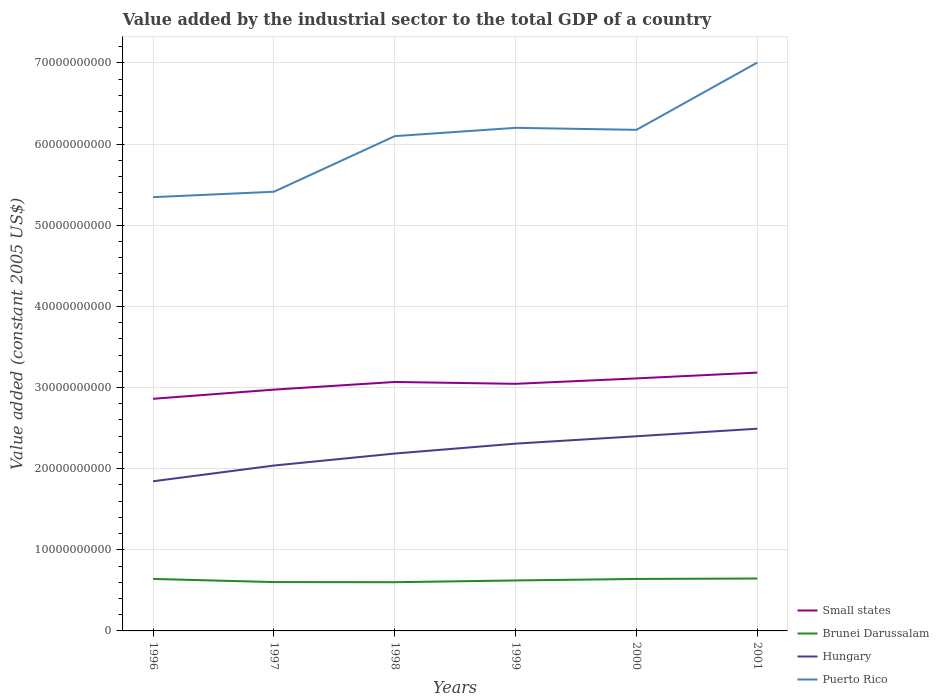Is the number of lines equal to the number of legend labels?
Offer a very short reply. Yes. Across all years, what is the maximum value added by the industrial sector in Small states?
Your answer should be very brief. 2.86e+1. In which year was the value added by the industrial sector in Hungary maximum?
Provide a short and direct response. 1996. What is the total value added by the industrial sector in Small states in the graph?
Offer a very short reply. -2.07e+09. What is the difference between the highest and the second highest value added by the industrial sector in Hungary?
Your answer should be very brief. 6.48e+09. How many lines are there?
Provide a short and direct response. 4. How many years are there in the graph?
Your answer should be very brief. 6. What is the difference between two consecutive major ticks on the Y-axis?
Offer a very short reply. 1.00e+1. Are the values on the major ticks of Y-axis written in scientific E-notation?
Your answer should be very brief. No. Where does the legend appear in the graph?
Provide a short and direct response. Bottom right. How many legend labels are there?
Provide a succinct answer. 4. What is the title of the graph?
Your answer should be very brief. Value added by the industrial sector to the total GDP of a country. What is the label or title of the X-axis?
Offer a terse response. Years. What is the label or title of the Y-axis?
Offer a terse response. Value added (constant 2005 US$). What is the Value added (constant 2005 US$) of Small states in 1996?
Provide a succinct answer. 2.86e+1. What is the Value added (constant 2005 US$) of Brunei Darussalam in 1996?
Offer a very short reply. 6.41e+09. What is the Value added (constant 2005 US$) of Hungary in 1996?
Ensure brevity in your answer.  1.84e+1. What is the Value added (constant 2005 US$) of Puerto Rico in 1996?
Give a very brief answer. 5.35e+1. What is the Value added (constant 2005 US$) in Small states in 1997?
Make the answer very short. 2.97e+1. What is the Value added (constant 2005 US$) in Brunei Darussalam in 1997?
Provide a succinct answer. 6.02e+09. What is the Value added (constant 2005 US$) of Hungary in 1997?
Offer a very short reply. 2.04e+1. What is the Value added (constant 2005 US$) in Puerto Rico in 1997?
Your answer should be compact. 5.41e+1. What is the Value added (constant 2005 US$) of Small states in 1998?
Provide a succinct answer. 3.07e+1. What is the Value added (constant 2005 US$) in Brunei Darussalam in 1998?
Your answer should be compact. 6.00e+09. What is the Value added (constant 2005 US$) in Hungary in 1998?
Give a very brief answer. 2.19e+1. What is the Value added (constant 2005 US$) of Puerto Rico in 1998?
Provide a succinct answer. 6.10e+1. What is the Value added (constant 2005 US$) in Small states in 1999?
Offer a terse response. 3.05e+1. What is the Value added (constant 2005 US$) of Brunei Darussalam in 1999?
Give a very brief answer. 6.22e+09. What is the Value added (constant 2005 US$) of Hungary in 1999?
Give a very brief answer. 2.31e+1. What is the Value added (constant 2005 US$) in Puerto Rico in 1999?
Your answer should be very brief. 6.20e+1. What is the Value added (constant 2005 US$) in Small states in 2000?
Offer a terse response. 3.11e+1. What is the Value added (constant 2005 US$) of Brunei Darussalam in 2000?
Your response must be concise. 6.40e+09. What is the Value added (constant 2005 US$) of Hungary in 2000?
Offer a very short reply. 2.40e+1. What is the Value added (constant 2005 US$) of Puerto Rico in 2000?
Give a very brief answer. 6.18e+1. What is the Value added (constant 2005 US$) in Small states in 2001?
Offer a very short reply. 3.18e+1. What is the Value added (constant 2005 US$) of Brunei Darussalam in 2001?
Ensure brevity in your answer.  6.46e+09. What is the Value added (constant 2005 US$) in Hungary in 2001?
Offer a terse response. 2.49e+1. What is the Value added (constant 2005 US$) in Puerto Rico in 2001?
Ensure brevity in your answer.  7.00e+1. Across all years, what is the maximum Value added (constant 2005 US$) in Small states?
Make the answer very short. 3.18e+1. Across all years, what is the maximum Value added (constant 2005 US$) in Brunei Darussalam?
Give a very brief answer. 6.46e+09. Across all years, what is the maximum Value added (constant 2005 US$) of Hungary?
Give a very brief answer. 2.49e+1. Across all years, what is the maximum Value added (constant 2005 US$) in Puerto Rico?
Offer a terse response. 7.00e+1. Across all years, what is the minimum Value added (constant 2005 US$) in Small states?
Provide a succinct answer. 2.86e+1. Across all years, what is the minimum Value added (constant 2005 US$) of Brunei Darussalam?
Keep it short and to the point. 6.00e+09. Across all years, what is the minimum Value added (constant 2005 US$) in Hungary?
Keep it short and to the point. 1.84e+1. Across all years, what is the minimum Value added (constant 2005 US$) of Puerto Rico?
Offer a terse response. 5.35e+1. What is the total Value added (constant 2005 US$) of Small states in the graph?
Make the answer very short. 1.82e+11. What is the total Value added (constant 2005 US$) in Brunei Darussalam in the graph?
Offer a terse response. 3.75e+1. What is the total Value added (constant 2005 US$) in Hungary in the graph?
Your answer should be compact. 1.33e+11. What is the total Value added (constant 2005 US$) of Puerto Rico in the graph?
Ensure brevity in your answer.  3.62e+11. What is the difference between the Value added (constant 2005 US$) of Small states in 1996 and that in 1997?
Offer a terse response. -1.13e+09. What is the difference between the Value added (constant 2005 US$) in Brunei Darussalam in 1996 and that in 1997?
Give a very brief answer. 3.89e+08. What is the difference between the Value added (constant 2005 US$) in Hungary in 1996 and that in 1997?
Provide a short and direct response. -1.94e+09. What is the difference between the Value added (constant 2005 US$) of Puerto Rico in 1996 and that in 1997?
Ensure brevity in your answer.  -6.69e+08. What is the difference between the Value added (constant 2005 US$) in Small states in 1996 and that in 1998?
Your answer should be compact. -2.07e+09. What is the difference between the Value added (constant 2005 US$) of Brunei Darussalam in 1996 and that in 1998?
Provide a short and direct response. 4.05e+08. What is the difference between the Value added (constant 2005 US$) of Hungary in 1996 and that in 1998?
Offer a very short reply. -3.42e+09. What is the difference between the Value added (constant 2005 US$) in Puerto Rico in 1996 and that in 1998?
Your answer should be compact. -7.52e+09. What is the difference between the Value added (constant 2005 US$) of Small states in 1996 and that in 1999?
Provide a short and direct response. -1.85e+09. What is the difference between the Value added (constant 2005 US$) of Brunei Darussalam in 1996 and that in 1999?
Provide a short and direct response. 1.89e+08. What is the difference between the Value added (constant 2005 US$) of Hungary in 1996 and that in 1999?
Keep it short and to the point. -4.64e+09. What is the difference between the Value added (constant 2005 US$) of Puerto Rico in 1996 and that in 1999?
Your answer should be very brief. -8.54e+09. What is the difference between the Value added (constant 2005 US$) in Small states in 1996 and that in 2000?
Your answer should be very brief. -2.51e+09. What is the difference between the Value added (constant 2005 US$) in Brunei Darussalam in 1996 and that in 2000?
Offer a terse response. 3.78e+06. What is the difference between the Value added (constant 2005 US$) in Hungary in 1996 and that in 2000?
Your answer should be compact. -5.55e+09. What is the difference between the Value added (constant 2005 US$) in Puerto Rico in 1996 and that in 2000?
Offer a terse response. -8.30e+09. What is the difference between the Value added (constant 2005 US$) of Small states in 1996 and that in 2001?
Offer a terse response. -3.23e+09. What is the difference between the Value added (constant 2005 US$) in Brunei Darussalam in 1996 and that in 2001?
Your response must be concise. -4.95e+07. What is the difference between the Value added (constant 2005 US$) in Hungary in 1996 and that in 2001?
Your answer should be very brief. -6.48e+09. What is the difference between the Value added (constant 2005 US$) in Puerto Rico in 1996 and that in 2001?
Make the answer very short. -1.66e+1. What is the difference between the Value added (constant 2005 US$) of Small states in 1997 and that in 1998?
Offer a terse response. -9.44e+08. What is the difference between the Value added (constant 2005 US$) of Brunei Darussalam in 1997 and that in 1998?
Provide a succinct answer. 1.59e+07. What is the difference between the Value added (constant 2005 US$) in Hungary in 1997 and that in 1998?
Your answer should be very brief. -1.48e+09. What is the difference between the Value added (constant 2005 US$) of Puerto Rico in 1997 and that in 1998?
Provide a short and direct response. -6.85e+09. What is the difference between the Value added (constant 2005 US$) in Small states in 1997 and that in 1999?
Your answer should be very brief. -7.16e+08. What is the difference between the Value added (constant 2005 US$) of Brunei Darussalam in 1997 and that in 1999?
Provide a short and direct response. -2.00e+08. What is the difference between the Value added (constant 2005 US$) in Hungary in 1997 and that in 1999?
Give a very brief answer. -2.70e+09. What is the difference between the Value added (constant 2005 US$) of Puerto Rico in 1997 and that in 1999?
Ensure brevity in your answer.  -7.87e+09. What is the difference between the Value added (constant 2005 US$) of Small states in 1997 and that in 2000?
Your response must be concise. -1.38e+09. What is the difference between the Value added (constant 2005 US$) in Brunei Darussalam in 1997 and that in 2000?
Your answer should be compact. -3.85e+08. What is the difference between the Value added (constant 2005 US$) in Hungary in 1997 and that in 2000?
Provide a succinct answer. -3.61e+09. What is the difference between the Value added (constant 2005 US$) in Puerto Rico in 1997 and that in 2000?
Provide a succinct answer. -7.63e+09. What is the difference between the Value added (constant 2005 US$) in Small states in 1997 and that in 2001?
Provide a succinct answer. -2.10e+09. What is the difference between the Value added (constant 2005 US$) of Brunei Darussalam in 1997 and that in 2001?
Make the answer very short. -4.39e+08. What is the difference between the Value added (constant 2005 US$) in Hungary in 1997 and that in 2001?
Your response must be concise. -4.54e+09. What is the difference between the Value added (constant 2005 US$) in Puerto Rico in 1997 and that in 2001?
Offer a very short reply. -1.59e+1. What is the difference between the Value added (constant 2005 US$) in Small states in 1998 and that in 1999?
Give a very brief answer. 2.28e+08. What is the difference between the Value added (constant 2005 US$) of Brunei Darussalam in 1998 and that in 1999?
Offer a very short reply. -2.16e+08. What is the difference between the Value added (constant 2005 US$) of Hungary in 1998 and that in 1999?
Keep it short and to the point. -1.22e+09. What is the difference between the Value added (constant 2005 US$) of Puerto Rico in 1998 and that in 1999?
Offer a terse response. -1.02e+09. What is the difference between the Value added (constant 2005 US$) in Small states in 1998 and that in 2000?
Provide a succinct answer. -4.40e+08. What is the difference between the Value added (constant 2005 US$) of Brunei Darussalam in 1998 and that in 2000?
Your answer should be very brief. -4.01e+08. What is the difference between the Value added (constant 2005 US$) in Hungary in 1998 and that in 2000?
Provide a succinct answer. -2.13e+09. What is the difference between the Value added (constant 2005 US$) of Puerto Rico in 1998 and that in 2000?
Your answer should be very brief. -7.76e+08. What is the difference between the Value added (constant 2005 US$) in Small states in 1998 and that in 2001?
Your answer should be compact. -1.16e+09. What is the difference between the Value added (constant 2005 US$) in Brunei Darussalam in 1998 and that in 2001?
Your answer should be very brief. -4.55e+08. What is the difference between the Value added (constant 2005 US$) of Hungary in 1998 and that in 2001?
Your answer should be compact. -3.06e+09. What is the difference between the Value added (constant 2005 US$) of Puerto Rico in 1998 and that in 2001?
Keep it short and to the point. -9.07e+09. What is the difference between the Value added (constant 2005 US$) of Small states in 1999 and that in 2000?
Your answer should be very brief. -6.68e+08. What is the difference between the Value added (constant 2005 US$) in Brunei Darussalam in 1999 and that in 2000?
Give a very brief answer. -1.85e+08. What is the difference between the Value added (constant 2005 US$) of Hungary in 1999 and that in 2000?
Provide a short and direct response. -9.09e+08. What is the difference between the Value added (constant 2005 US$) of Puerto Rico in 1999 and that in 2000?
Ensure brevity in your answer.  2.48e+08. What is the difference between the Value added (constant 2005 US$) of Small states in 1999 and that in 2001?
Keep it short and to the point. -1.38e+09. What is the difference between the Value added (constant 2005 US$) of Brunei Darussalam in 1999 and that in 2001?
Your answer should be very brief. -2.39e+08. What is the difference between the Value added (constant 2005 US$) of Hungary in 1999 and that in 2001?
Give a very brief answer. -1.84e+09. What is the difference between the Value added (constant 2005 US$) of Puerto Rico in 1999 and that in 2001?
Your response must be concise. -8.04e+09. What is the difference between the Value added (constant 2005 US$) in Small states in 2000 and that in 2001?
Make the answer very short. -7.15e+08. What is the difference between the Value added (constant 2005 US$) of Brunei Darussalam in 2000 and that in 2001?
Your answer should be compact. -5.32e+07. What is the difference between the Value added (constant 2005 US$) in Hungary in 2000 and that in 2001?
Offer a terse response. -9.31e+08. What is the difference between the Value added (constant 2005 US$) of Puerto Rico in 2000 and that in 2001?
Your answer should be very brief. -8.29e+09. What is the difference between the Value added (constant 2005 US$) of Small states in 1996 and the Value added (constant 2005 US$) of Brunei Darussalam in 1997?
Make the answer very short. 2.26e+1. What is the difference between the Value added (constant 2005 US$) of Small states in 1996 and the Value added (constant 2005 US$) of Hungary in 1997?
Offer a terse response. 8.23e+09. What is the difference between the Value added (constant 2005 US$) in Small states in 1996 and the Value added (constant 2005 US$) in Puerto Rico in 1997?
Offer a very short reply. -2.55e+1. What is the difference between the Value added (constant 2005 US$) of Brunei Darussalam in 1996 and the Value added (constant 2005 US$) of Hungary in 1997?
Make the answer very short. -1.40e+1. What is the difference between the Value added (constant 2005 US$) of Brunei Darussalam in 1996 and the Value added (constant 2005 US$) of Puerto Rico in 1997?
Offer a terse response. -4.77e+1. What is the difference between the Value added (constant 2005 US$) of Hungary in 1996 and the Value added (constant 2005 US$) of Puerto Rico in 1997?
Your answer should be compact. -3.57e+1. What is the difference between the Value added (constant 2005 US$) of Small states in 1996 and the Value added (constant 2005 US$) of Brunei Darussalam in 1998?
Your response must be concise. 2.26e+1. What is the difference between the Value added (constant 2005 US$) of Small states in 1996 and the Value added (constant 2005 US$) of Hungary in 1998?
Offer a very short reply. 6.75e+09. What is the difference between the Value added (constant 2005 US$) of Small states in 1996 and the Value added (constant 2005 US$) of Puerto Rico in 1998?
Give a very brief answer. -3.24e+1. What is the difference between the Value added (constant 2005 US$) in Brunei Darussalam in 1996 and the Value added (constant 2005 US$) in Hungary in 1998?
Offer a very short reply. -1.55e+1. What is the difference between the Value added (constant 2005 US$) in Brunei Darussalam in 1996 and the Value added (constant 2005 US$) in Puerto Rico in 1998?
Offer a terse response. -5.46e+1. What is the difference between the Value added (constant 2005 US$) in Hungary in 1996 and the Value added (constant 2005 US$) in Puerto Rico in 1998?
Make the answer very short. -4.25e+1. What is the difference between the Value added (constant 2005 US$) in Small states in 1996 and the Value added (constant 2005 US$) in Brunei Darussalam in 1999?
Offer a terse response. 2.24e+1. What is the difference between the Value added (constant 2005 US$) of Small states in 1996 and the Value added (constant 2005 US$) of Hungary in 1999?
Give a very brief answer. 5.53e+09. What is the difference between the Value added (constant 2005 US$) in Small states in 1996 and the Value added (constant 2005 US$) in Puerto Rico in 1999?
Your answer should be compact. -3.34e+1. What is the difference between the Value added (constant 2005 US$) in Brunei Darussalam in 1996 and the Value added (constant 2005 US$) in Hungary in 1999?
Your response must be concise. -1.67e+1. What is the difference between the Value added (constant 2005 US$) in Brunei Darussalam in 1996 and the Value added (constant 2005 US$) in Puerto Rico in 1999?
Offer a terse response. -5.56e+1. What is the difference between the Value added (constant 2005 US$) in Hungary in 1996 and the Value added (constant 2005 US$) in Puerto Rico in 1999?
Offer a terse response. -4.36e+1. What is the difference between the Value added (constant 2005 US$) of Small states in 1996 and the Value added (constant 2005 US$) of Brunei Darussalam in 2000?
Offer a very short reply. 2.22e+1. What is the difference between the Value added (constant 2005 US$) in Small states in 1996 and the Value added (constant 2005 US$) in Hungary in 2000?
Keep it short and to the point. 4.62e+09. What is the difference between the Value added (constant 2005 US$) in Small states in 1996 and the Value added (constant 2005 US$) in Puerto Rico in 2000?
Your response must be concise. -3.31e+1. What is the difference between the Value added (constant 2005 US$) of Brunei Darussalam in 1996 and the Value added (constant 2005 US$) of Hungary in 2000?
Offer a very short reply. -1.76e+1. What is the difference between the Value added (constant 2005 US$) of Brunei Darussalam in 1996 and the Value added (constant 2005 US$) of Puerto Rico in 2000?
Offer a very short reply. -5.53e+1. What is the difference between the Value added (constant 2005 US$) of Hungary in 1996 and the Value added (constant 2005 US$) of Puerto Rico in 2000?
Give a very brief answer. -4.33e+1. What is the difference between the Value added (constant 2005 US$) of Small states in 1996 and the Value added (constant 2005 US$) of Brunei Darussalam in 2001?
Provide a short and direct response. 2.21e+1. What is the difference between the Value added (constant 2005 US$) in Small states in 1996 and the Value added (constant 2005 US$) in Hungary in 2001?
Provide a short and direct response. 3.69e+09. What is the difference between the Value added (constant 2005 US$) of Small states in 1996 and the Value added (constant 2005 US$) of Puerto Rico in 2001?
Ensure brevity in your answer.  -4.14e+1. What is the difference between the Value added (constant 2005 US$) of Brunei Darussalam in 1996 and the Value added (constant 2005 US$) of Hungary in 2001?
Provide a succinct answer. -1.85e+1. What is the difference between the Value added (constant 2005 US$) in Brunei Darussalam in 1996 and the Value added (constant 2005 US$) in Puerto Rico in 2001?
Your answer should be very brief. -6.36e+1. What is the difference between the Value added (constant 2005 US$) of Hungary in 1996 and the Value added (constant 2005 US$) of Puerto Rico in 2001?
Your answer should be very brief. -5.16e+1. What is the difference between the Value added (constant 2005 US$) in Small states in 1997 and the Value added (constant 2005 US$) in Brunei Darussalam in 1998?
Make the answer very short. 2.37e+1. What is the difference between the Value added (constant 2005 US$) of Small states in 1997 and the Value added (constant 2005 US$) of Hungary in 1998?
Your answer should be compact. 7.88e+09. What is the difference between the Value added (constant 2005 US$) in Small states in 1997 and the Value added (constant 2005 US$) in Puerto Rico in 1998?
Your answer should be very brief. -3.12e+1. What is the difference between the Value added (constant 2005 US$) in Brunei Darussalam in 1997 and the Value added (constant 2005 US$) in Hungary in 1998?
Your answer should be compact. -1.58e+1. What is the difference between the Value added (constant 2005 US$) in Brunei Darussalam in 1997 and the Value added (constant 2005 US$) in Puerto Rico in 1998?
Provide a short and direct response. -5.50e+1. What is the difference between the Value added (constant 2005 US$) of Hungary in 1997 and the Value added (constant 2005 US$) of Puerto Rico in 1998?
Provide a short and direct response. -4.06e+1. What is the difference between the Value added (constant 2005 US$) of Small states in 1997 and the Value added (constant 2005 US$) of Brunei Darussalam in 1999?
Your response must be concise. 2.35e+1. What is the difference between the Value added (constant 2005 US$) in Small states in 1997 and the Value added (constant 2005 US$) in Hungary in 1999?
Provide a short and direct response. 6.66e+09. What is the difference between the Value added (constant 2005 US$) in Small states in 1997 and the Value added (constant 2005 US$) in Puerto Rico in 1999?
Provide a succinct answer. -3.23e+1. What is the difference between the Value added (constant 2005 US$) of Brunei Darussalam in 1997 and the Value added (constant 2005 US$) of Hungary in 1999?
Your answer should be compact. -1.71e+1. What is the difference between the Value added (constant 2005 US$) in Brunei Darussalam in 1997 and the Value added (constant 2005 US$) in Puerto Rico in 1999?
Make the answer very short. -5.60e+1. What is the difference between the Value added (constant 2005 US$) in Hungary in 1997 and the Value added (constant 2005 US$) in Puerto Rico in 1999?
Provide a short and direct response. -4.16e+1. What is the difference between the Value added (constant 2005 US$) of Small states in 1997 and the Value added (constant 2005 US$) of Brunei Darussalam in 2000?
Give a very brief answer. 2.33e+1. What is the difference between the Value added (constant 2005 US$) of Small states in 1997 and the Value added (constant 2005 US$) of Hungary in 2000?
Your answer should be compact. 5.75e+09. What is the difference between the Value added (constant 2005 US$) in Small states in 1997 and the Value added (constant 2005 US$) in Puerto Rico in 2000?
Your response must be concise. -3.20e+1. What is the difference between the Value added (constant 2005 US$) in Brunei Darussalam in 1997 and the Value added (constant 2005 US$) in Hungary in 2000?
Your answer should be very brief. -1.80e+1. What is the difference between the Value added (constant 2005 US$) of Brunei Darussalam in 1997 and the Value added (constant 2005 US$) of Puerto Rico in 2000?
Provide a succinct answer. -5.57e+1. What is the difference between the Value added (constant 2005 US$) in Hungary in 1997 and the Value added (constant 2005 US$) in Puerto Rico in 2000?
Make the answer very short. -4.14e+1. What is the difference between the Value added (constant 2005 US$) of Small states in 1997 and the Value added (constant 2005 US$) of Brunei Darussalam in 2001?
Make the answer very short. 2.33e+1. What is the difference between the Value added (constant 2005 US$) in Small states in 1997 and the Value added (constant 2005 US$) in Hungary in 2001?
Your response must be concise. 4.82e+09. What is the difference between the Value added (constant 2005 US$) in Small states in 1997 and the Value added (constant 2005 US$) in Puerto Rico in 2001?
Offer a terse response. -4.03e+1. What is the difference between the Value added (constant 2005 US$) of Brunei Darussalam in 1997 and the Value added (constant 2005 US$) of Hungary in 2001?
Give a very brief answer. -1.89e+1. What is the difference between the Value added (constant 2005 US$) of Brunei Darussalam in 1997 and the Value added (constant 2005 US$) of Puerto Rico in 2001?
Keep it short and to the point. -6.40e+1. What is the difference between the Value added (constant 2005 US$) of Hungary in 1997 and the Value added (constant 2005 US$) of Puerto Rico in 2001?
Your answer should be compact. -4.97e+1. What is the difference between the Value added (constant 2005 US$) of Small states in 1998 and the Value added (constant 2005 US$) of Brunei Darussalam in 1999?
Offer a terse response. 2.45e+1. What is the difference between the Value added (constant 2005 US$) of Small states in 1998 and the Value added (constant 2005 US$) of Hungary in 1999?
Offer a very short reply. 7.60e+09. What is the difference between the Value added (constant 2005 US$) in Small states in 1998 and the Value added (constant 2005 US$) in Puerto Rico in 1999?
Keep it short and to the point. -3.13e+1. What is the difference between the Value added (constant 2005 US$) of Brunei Darussalam in 1998 and the Value added (constant 2005 US$) of Hungary in 1999?
Make the answer very short. -1.71e+1. What is the difference between the Value added (constant 2005 US$) of Brunei Darussalam in 1998 and the Value added (constant 2005 US$) of Puerto Rico in 1999?
Provide a short and direct response. -5.60e+1. What is the difference between the Value added (constant 2005 US$) of Hungary in 1998 and the Value added (constant 2005 US$) of Puerto Rico in 1999?
Offer a very short reply. -4.01e+1. What is the difference between the Value added (constant 2005 US$) in Small states in 1998 and the Value added (constant 2005 US$) in Brunei Darussalam in 2000?
Offer a very short reply. 2.43e+1. What is the difference between the Value added (constant 2005 US$) in Small states in 1998 and the Value added (constant 2005 US$) in Hungary in 2000?
Offer a terse response. 6.69e+09. What is the difference between the Value added (constant 2005 US$) in Small states in 1998 and the Value added (constant 2005 US$) in Puerto Rico in 2000?
Give a very brief answer. -3.11e+1. What is the difference between the Value added (constant 2005 US$) in Brunei Darussalam in 1998 and the Value added (constant 2005 US$) in Hungary in 2000?
Your answer should be compact. -1.80e+1. What is the difference between the Value added (constant 2005 US$) of Brunei Darussalam in 1998 and the Value added (constant 2005 US$) of Puerto Rico in 2000?
Give a very brief answer. -5.57e+1. What is the difference between the Value added (constant 2005 US$) in Hungary in 1998 and the Value added (constant 2005 US$) in Puerto Rico in 2000?
Offer a terse response. -3.99e+1. What is the difference between the Value added (constant 2005 US$) in Small states in 1998 and the Value added (constant 2005 US$) in Brunei Darussalam in 2001?
Offer a very short reply. 2.42e+1. What is the difference between the Value added (constant 2005 US$) of Small states in 1998 and the Value added (constant 2005 US$) of Hungary in 2001?
Give a very brief answer. 5.76e+09. What is the difference between the Value added (constant 2005 US$) of Small states in 1998 and the Value added (constant 2005 US$) of Puerto Rico in 2001?
Provide a succinct answer. -3.94e+1. What is the difference between the Value added (constant 2005 US$) in Brunei Darussalam in 1998 and the Value added (constant 2005 US$) in Hungary in 2001?
Provide a succinct answer. -1.89e+1. What is the difference between the Value added (constant 2005 US$) of Brunei Darussalam in 1998 and the Value added (constant 2005 US$) of Puerto Rico in 2001?
Offer a terse response. -6.40e+1. What is the difference between the Value added (constant 2005 US$) in Hungary in 1998 and the Value added (constant 2005 US$) in Puerto Rico in 2001?
Your response must be concise. -4.82e+1. What is the difference between the Value added (constant 2005 US$) in Small states in 1999 and the Value added (constant 2005 US$) in Brunei Darussalam in 2000?
Your answer should be compact. 2.40e+1. What is the difference between the Value added (constant 2005 US$) in Small states in 1999 and the Value added (constant 2005 US$) in Hungary in 2000?
Provide a succinct answer. 6.46e+09. What is the difference between the Value added (constant 2005 US$) in Small states in 1999 and the Value added (constant 2005 US$) in Puerto Rico in 2000?
Your response must be concise. -3.13e+1. What is the difference between the Value added (constant 2005 US$) of Brunei Darussalam in 1999 and the Value added (constant 2005 US$) of Hungary in 2000?
Ensure brevity in your answer.  -1.78e+1. What is the difference between the Value added (constant 2005 US$) of Brunei Darussalam in 1999 and the Value added (constant 2005 US$) of Puerto Rico in 2000?
Offer a terse response. -5.55e+1. What is the difference between the Value added (constant 2005 US$) of Hungary in 1999 and the Value added (constant 2005 US$) of Puerto Rico in 2000?
Offer a terse response. -3.87e+1. What is the difference between the Value added (constant 2005 US$) in Small states in 1999 and the Value added (constant 2005 US$) in Brunei Darussalam in 2001?
Your answer should be compact. 2.40e+1. What is the difference between the Value added (constant 2005 US$) in Small states in 1999 and the Value added (constant 2005 US$) in Hungary in 2001?
Provide a succinct answer. 5.53e+09. What is the difference between the Value added (constant 2005 US$) of Small states in 1999 and the Value added (constant 2005 US$) of Puerto Rico in 2001?
Ensure brevity in your answer.  -3.96e+1. What is the difference between the Value added (constant 2005 US$) of Brunei Darussalam in 1999 and the Value added (constant 2005 US$) of Hungary in 2001?
Your answer should be very brief. -1.87e+1. What is the difference between the Value added (constant 2005 US$) of Brunei Darussalam in 1999 and the Value added (constant 2005 US$) of Puerto Rico in 2001?
Your answer should be compact. -6.38e+1. What is the difference between the Value added (constant 2005 US$) in Hungary in 1999 and the Value added (constant 2005 US$) in Puerto Rico in 2001?
Your response must be concise. -4.70e+1. What is the difference between the Value added (constant 2005 US$) of Small states in 2000 and the Value added (constant 2005 US$) of Brunei Darussalam in 2001?
Offer a terse response. 2.47e+1. What is the difference between the Value added (constant 2005 US$) in Small states in 2000 and the Value added (constant 2005 US$) in Hungary in 2001?
Ensure brevity in your answer.  6.20e+09. What is the difference between the Value added (constant 2005 US$) in Small states in 2000 and the Value added (constant 2005 US$) in Puerto Rico in 2001?
Offer a very short reply. -3.89e+1. What is the difference between the Value added (constant 2005 US$) in Brunei Darussalam in 2000 and the Value added (constant 2005 US$) in Hungary in 2001?
Offer a very short reply. -1.85e+1. What is the difference between the Value added (constant 2005 US$) in Brunei Darussalam in 2000 and the Value added (constant 2005 US$) in Puerto Rico in 2001?
Give a very brief answer. -6.36e+1. What is the difference between the Value added (constant 2005 US$) in Hungary in 2000 and the Value added (constant 2005 US$) in Puerto Rico in 2001?
Your answer should be very brief. -4.61e+1. What is the average Value added (constant 2005 US$) in Small states per year?
Provide a short and direct response. 3.04e+1. What is the average Value added (constant 2005 US$) of Brunei Darussalam per year?
Provide a succinct answer. 6.25e+09. What is the average Value added (constant 2005 US$) in Hungary per year?
Provide a short and direct response. 2.21e+1. What is the average Value added (constant 2005 US$) in Puerto Rico per year?
Ensure brevity in your answer.  6.04e+1. In the year 1996, what is the difference between the Value added (constant 2005 US$) of Small states and Value added (constant 2005 US$) of Brunei Darussalam?
Offer a very short reply. 2.22e+1. In the year 1996, what is the difference between the Value added (constant 2005 US$) in Small states and Value added (constant 2005 US$) in Hungary?
Offer a very short reply. 1.02e+1. In the year 1996, what is the difference between the Value added (constant 2005 US$) in Small states and Value added (constant 2005 US$) in Puerto Rico?
Offer a terse response. -2.49e+1. In the year 1996, what is the difference between the Value added (constant 2005 US$) in Brunei Darussalam and Value added (constant 2005 US$) in Hungary?
Provide a short and direct response. -1.20e+1. In the year 1996, what is the difference between the Value added (constant 2005 US$) of Brunei Darussalam and Value added (constant 2005 US$) of Puerto Rico?
Keep it short and to the point. -4.70e+1. In the year 1996, what is the difference between the Value added (constant 2005 US$) in Hungary and Value added (constant 2005 US$) in Puerto Rico?
Keep it short and to the point. -3.50e+1. In the year 1997, what is the difference between the Value added (constant 2005 US$) in Small states and Value added (constant 2005 US$) in Brunei Darussalam?
Your answer should be compact. 2.37e+1. In the year 1997, what is the difference between the Value added (constant 2005 US$) in Small states and Value added (constant 2005 US$) in Hungary?
Provide a short and direct response. 9.36e+09. In the year 1997, what is the difference between the Value added (constant 2005 US$) in Small states and Value added (constant 2005 US$) in Puerto Rico?
Provide a succinct answer. -2.44e+1. In the year 1997, what is the difference between the Value added (constant 2005 US$) of Brunei Darussalam and Value added (constant 2005 US$) of Hungary?
Offer a terse response. -1.44e+1. In the year 1997, what is the difference between the Value added (constant 2005 US$) of Brunei Darussalam and Value added (constant 2005 US$) of Puerto Rico?
Your answer should be compact. -4.81e+1. In the year 1997, what is the difference between the Value added (constant 2005 US$) in Hungary and Value added (constant 2005 US$) in Puerto Rico?
Your answer should be compact. -3.37e+1. In the year 1998, what is the difference between the Value added (constant 2005 US$) in Small states and Value added (constant 2005 US$) in Brunei Darussalam?
Your answer should be very brief. 2.47e+1. In the year 1998, what is the difference between the Value added (constant 2005 US$) in Small states and Value added (constant 2005 US$) in Hungary?
Keep it short and to the point. 8.82e+09. In the year 1998, what is the difference between the Value added (constant 2005 US$) in Small states and Value added (constant 2005 US$) in Puerto Rico?
Your answer should be compact. -3.03e+1. In the year 1998, what is the difference between the Value added (constant 2005 US$) of Brunei Darussalam and Value added (constant 2005 US$) of Hungary?
Offer a very short reply. -1.59e+1. In the year 1998, what is the difference between the Value added (constant 2005 US$) of Brunei Darussalam and Value added (constant 2005 US$) of Puerto Rico?
Offer a very short reply. -5.50e+1. In the year 1998, what is the difference between the Value added (constant 2005 US$) in Hungary and Value added (constant 2005 US$) in Puerto Rico?
Keep it short and to the point. -3.91e+1. In the year 1999, what is the difference between the Value added (constant 2005 US$) of Small states and Value added (constant 2005 US$) of Brunei Darussalam?
Your answer should be compact. 2.42e+1. In the year 1999, what is the difference between the Value added (constant 2005 US$) in Small states and Value added (constant 2005 US$) in Hungary?
Your answer should be very brief. 7.37e+09. In the year 1999, what is the difference between the Value added (constant 2005 US$) of Small states and Value added (constant 2005 US$) of Puerto Rico?
Provide a succinct answer. -3.15e+1. In the year 1999, what is the difference between the Value added (constant 2005 US$) in Brunei Darussalam and Value added (constant 2005 US$) in Hungary?
Your answer should be compact. -1.69e+1. In the year 1999, what is the difference between the Value added (constant 2005 US$) of Brunei Darussalam and Value added (constant 2005 US$) of Puerto Rico?
Keep it short and to the point. -5.58e+1. In the year 1999, what is the difference between the Value added (constant 2005 US$) in Hungary and Value added (constant 2005 US$) in Puerto Rico?
Ensure brevity in your answer.  -3.89e+1. In the year 2000, what is the difference between the Value added (constant 2005 US$) of Small states and Value added (constant 2005 US$) of Brunei Darussalam?
Offer a terse response. 2.47e+1. In the year 2000, what is the difference between the Value added (constant 2005 US$) in Small states and Value added (constant 2005 US$) in Hungary?
Your response must be concise. 7.13e+09. In the year 2000, what is the difference between the Value added (constant 2005 US$) in Small states and Value added (constant 2005 US$) in Puerto Rico?
Your answer should be compact. -3.06e+1. In the year 2000, what is the difference between the Value added (constant 2005 US$) of Brunei Darussalam and Value added (constant 2005 US$) of Hungary?
Your response must be concise. -1.76e+1. In the year 2000, what is the difference between the Value added (constant 2005 US$) in Brunei Darussalam and Value added (constant 2005 US$) in Puerto Rico?
Your response must be concise. -5.53e+1. In the year 2000, what is the difference between the Value added (constant 2005 US$) of Hungary and Value added (constant 2005 US$) of Puerto Rico?
Your answer should be very brief. -3.78e+1. In the year 2001, what is the difference between the Value added (constant 2005 US$) in Small states and Value added (constant 2005 US$) in Brunei Darussalam?
Keep it short and to the point. 2.54e+1. In the year 2001, what is the difference between the Value added (constant 2005 US$) in Small states and Value added (constant 2005 US$) in Hungary?
Your response must be concise. 6.92e+09. In the year 2001, what is the difference between the Value added (constant 2005 US$) of Small states and Value added (constant 2005 US$) of Puerto Rico?
Give a very brief answer. -3.82e+1. In the year 2001, what is the difference between the Value added (constant 2005 US$) of Brunei Darussalam and Value added (constant 2005 US$) of Hungary?
Offer a terse response. -1.85e+1. In the year 2001, what is the difference between the Value added (constant 2005 US$) of Brunei Darussalam and Value added (constant 2005 US$) of Puerto Rico?
Keep it short and to the point. -6.36e+1. In the year 2001, what is the difference between the Value added (constant 2005 US$) in Hungary and Value added (constant 2005 US$) in Puerto Rico?
Give a very brief answer. -4.51e+1. What is the ratio of the Value added (constant 2005 US$) of Small states in 1996 to that in 1997?
Give a very brief answer. 0.96. What is the ratio of the Value added (constant 2005 US$) in Brunei Darussalam in 1996 to that in 1997?
Your answer should be very brief. 1.06. What is the ratio of the Value added (constant 2005 US$) in Hungary in 1996 to that in 1997?
Make the answer very short. 0.9. What is the ratio of the Value added (constant 2005 US$) of Puerto Rico in 1996 to that in 1997?
Offer a very short reply. 0.99. What is the ratio of the Value added (constant 2005 US$) in Small states in 1996 to that in 1998?
Your answer should be compact. 0.93. What is the ratio of the Value added (constant 2005 US$) of Brunei Darussalam in 1996 to that in 1998?
Keep it short and to the point. 1.07. What is the ratio of the Value added (constant 2005 US$) in Hungary in 1996 to that in 1998?
Offer a very short reply. 0.84. What is the ratio of the Value added (constant 2005 US$) of Puerto Rico in 1996 to that in 1998?
Give a very brief answer. 0.88. What is the ratio of the Value added (constant 2005 US$) in Small states in 1996 to that in 1999?
Provide a short and direct response. 0.94. What is the ratio of the Value added (constant 2005 US$) in Brunei Darussalam in 1996 to that in 1999?
Give a very brief answer. 1.03. What is the ratio of the Value added (constant 2005 US$) of Hungary in 1996 to that in 1999?
Ensure brevity in your answer.  0.8. What is the ratio of the Value added (constant 2005 US$) of Puerto Rico in 1996 to that in 1999?
Your answer should be compact. 0.86. What is the ratio of the Value added (constant 2005 US$) of Small states in 1996 to that in 2000?
Provide a short and direct response. 0.92. What is the ratio of the Value added (constant 2005 US$) of Hungary in 1996 to that in 2000?
Your answer should be very brief. 0.77. What is the ratio of the Value added (constant 2005 US$) in Puerto Rico in 1996 to that in 2000?
Give a very brief answer. 0.87. What is the ratio of the Value added (constant 2005 US$) in Small states in 1996 to that in 2001?
Your answer should be very brief. 0.9. What is the ratio of the Value added (constant 2005 US$) in Brunei Darussalam in 1996 to that in 2001?
Provide a short and direct response. 0.99. What is the ratio of the Value added (constant 2005 US$) of Hungary in 1996 to that in 2001?
Your response must be concise. 0.74. What is the ratio of the Value added (constant 2005 US$) of Puerto Rico in 1996 to that in 2001?
Offer a terse response. 0.76. What is the ratio of the Value added (constant 2005 US$) of Small states in 1997 to that in 1998?
Offer a very short reply. 0.97. What is the ratio of the Value added (constant 2005 US$) of Hungary in 1997 to that in 1998?
Your response must be concise. 0.93. What is the ratio of the Value added (constant 2005 US$) in Puerto Rico in 1997 to that in 1998?
Keep it short and to the point. 0.89. What is the ratio of the Value added (constant 2005 US$) of Small states in 1997 to that in 1999?
Make the answer very short. 0.98. What is the ratio of the Value added (constant 2005 US$) in Brunei Darussalam in 1997 to that in 1999?
Your answer should be compact. 0.97. What is the ratio of the Value added (constant 2005 US$) in Hungary in 1997 to that in 1999?
Provide a short and direct response. 0.88. What is the ratio of the Value added (constant 2005 US$) in Puerto Rico in 1997 to that in 1999?
Your answer should be very brief. 0.87. What is the ratio of the Value added (constant 2005 US$) in Small states in 1997 to that in 2000?
Your answer should be compact. 0.96. What is the ratio of the Value added (constant 2005 US$) in Brunei Darussalam in 1997 to that in 2000?
Make the answer very short. 0.94. What is the ratio of the Value added (constant 2005 US$) in Hungary in 1997 to that in 2000?
Provide a short and direct response. 0.85. What is the ratio of the Value added (constant 2005 US$) of Puerto Rico in 1997 to that in 2000?
Keep it short and to the point. 0.88. What is the ratio of the Value added (constant 2005 US$) in Small states in 1997 to that in 2001?
Offer a terse response. 0.93. What is the ratio of the Value added (constant 2005 US$) in Brunei Darussalam in 1997 to that in 2001?
Offer a very short reply. 0.93. What is the ratio of the Value added (constant 2005 US$) in Hungary in 1997 to that in 2001?
Make the answer very short. 0.82. What is the ratio of the Value added (constant 2005 US$) in Puerto Rico in 1997 to that in 2001?
Provide a succinct answer. 0.77. What is the ratio of the Value added (constant 2005 US$) in Small states in 1998 to that in 1999?
Make the answer very short. 1.01. What is the ratio of the Value added (constant 2005 US$) of Brunei Darussalam in 1998 to that in 1999?
Your answer should be compact. 0.97. What is the ratio of the Value added (constant 2005 US$) of Hungary in 1998 to that in 1999?
Provide a short and direct response. 0.95. What is the ratio of the Value added (constant 2005 US$) of Puerto Rico in 1998 to that in 1999?
Provide a succinct answer. 0.98. What is the ratio of the Value added (constant 2005 US$) in Small states in 1998 to that in 2000?
Make the answer very short. 0.99. What is the ratio of the Value added (constant 2005 US$) of Brunei Darussalam in 1998 to that in 2000?
Keep it short and to the point. 0.94. What is the ratio of the Value added (constant 2005 US$) of Hungary in 1998 to that in 2000?
Make the answer very short. 0.91. What is the ratio of the Value added (constant 2005 US$) of Puerto Rico in 1998 to that in 2000?
Offer a very short reply. 0.99. What is the ratio of the Value added (constant 2005 US$) of Small states in 1998 to that in 2001?
Give a very brief answer. 0.96. What is the ratio of the Value added (constant 2005 US$) in Brunei Darussalam in 1998 to that in 2001?
Give a very brief answer. 0.93. What is the ratio of the Value added (constant 2005 US$) in Hungary in 1998 to that in 2001?
Provide a short and direct response. 0.88. What is the ratio of the Value added (constant 2005 US$) of Puerto Rico in 1998 to that in 2001?
Provide a succinct answer. 0.87. What is the ratio of the Value added (constant 2005 US$) in Small states in 1999 to that in 2000?
Provide a short and direct response. 0.98. What is the ratio of the Value added (constant 2005 US$) in Brunei Darussalam in 1999 to that in 2000?
Your answer should be compact. 0.97. What is the ratio of the Value added (constant 2005 US$) in Hungary in 1999 to that in 2000?
Your response must be concise. 0.96. What is the ratio of the Value added (constant 2005 US$) in Puerto Rico in 1999 to that in 2000?
Your response must be concise. 1. What is the ratio of the Value added (constant 2005 US$) in Small states in 1999 to that in 2001?
Offer a very short reply. 0.96. What is the ratio of the Value added (constant 2005 US$) of Brunei Darussalam in 1999 to that in 2001?
Your response must be concise. 0.96. What is the ratio of the Value added (constant 2005 US$) of Hungary in 1999 to that in 2001?
Ensure brevity in your answer.  0.93. What is the ratio of the Value added (constant 2005 US$) in Puerto Rico in 1999 to that in 2001?
Keep it short and to the point. 0.89. What is the ratio of the Value added (constant 2005 US$) in Small states in 2000 to that in 2001?
Offer a terse response. 0.98. What is the ratio of the Value added (constant 2005 US$) of Brunei Darussalam in 2000 to that in 2001?
Offer a very short reply. 0.99. What is the ratio of the Value added (constant 2005 US$) of Hungary in 2000 to that in 2001?
Provide a succinct answer. 0.96. What is the ratio of the Value added (constant 2005 US$) of Puerto Rico in 2000 to that in 2001?
Make the answer very short. 0.88. What is the difference between the highest and the second highest Value added (constant 2005 US$) in Small states?
Offer a terse response. 7.15e+08. What is the difference between the highest and the second highest Value added (constant 2005 US$) of Brunei Darussalam?
Your answer should be very brief. 4.95e+07. What is the difference between the highest and the second highest Value added (constant 2005 US$) of Hungary?
Offer a very short reply. 9.31e+08. What is the difference between the highest and the second highest Value added (constant 2005 US$) in Puerto Rico?
Make the answer very short. 8.04e+09. What is the difference between the highest and the lowest Value added (constant 2005 US$) of Small states?
Offer a very short reply. 3.23e+09. What is the difference between the highest and the lowest Value added (constant 2005 US$) of Brunei Darussalam?
Provide a short and direct response. 4.55e+08. What is the difference between the highest and the lowest Value added (constant 2005 US$) of Hungary?
Make the answer very short. 6.48e+09. What is the difference between the highest and the lowest Value added (constant 2005 US$) in Puerto Rico?
Your answer should be compact. 1.66e+1. 